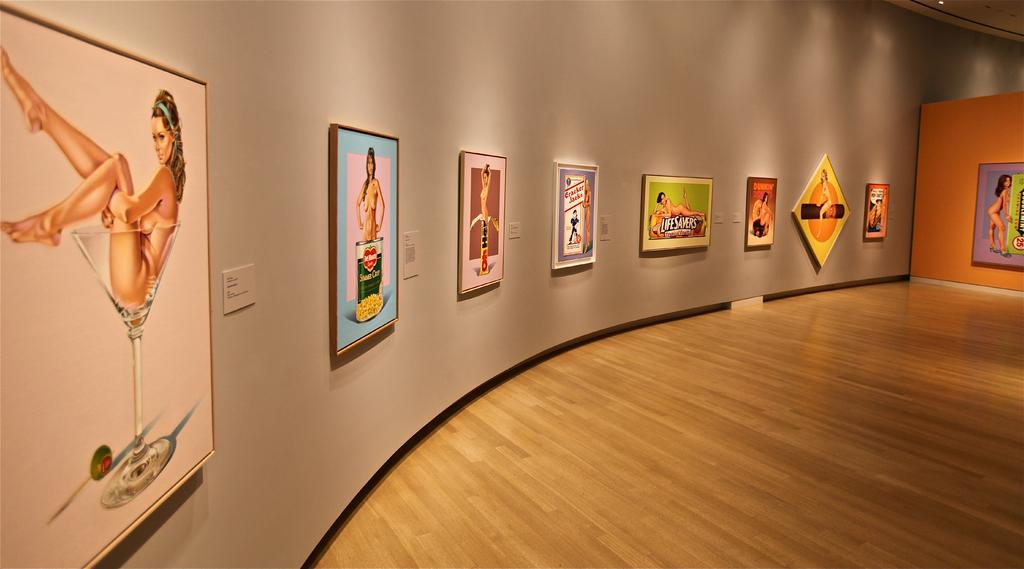Where was the image taken? The image was taken inside a building. What can be seen on the walls in the image? There is a wall visible in the image, and there are photo frames of persons on the wall. What type of whip can be seen in the photo frames on the wall? There is no whip present in the photo frames or in the image. 